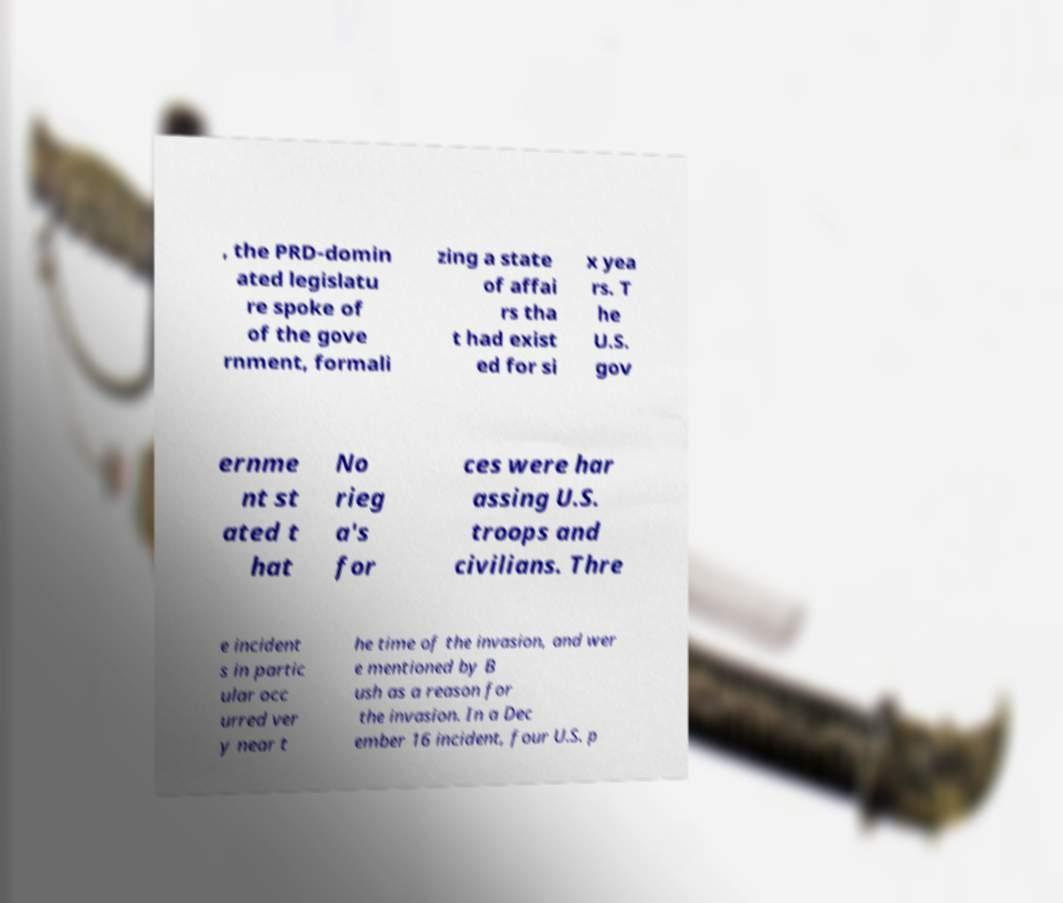There's text embedded in this image that I need extracted. Can you transcribe it verbatim? , the PRD-domin ated legislatu re spoke of of the gove rnment, formali zing a state of affai rs tha t had exist ed for si x yea rs. T he U.S. gov ernme nt st ated t hat No rieg a's for ces were har assing U.S. troops and civilians. Thre e incident s in partic ular occ urred ver y near t he time of the invasion, and wer e mentioned by B ush as a reason for the invasion. In a Dec ember 16 incident, four U.S. p 